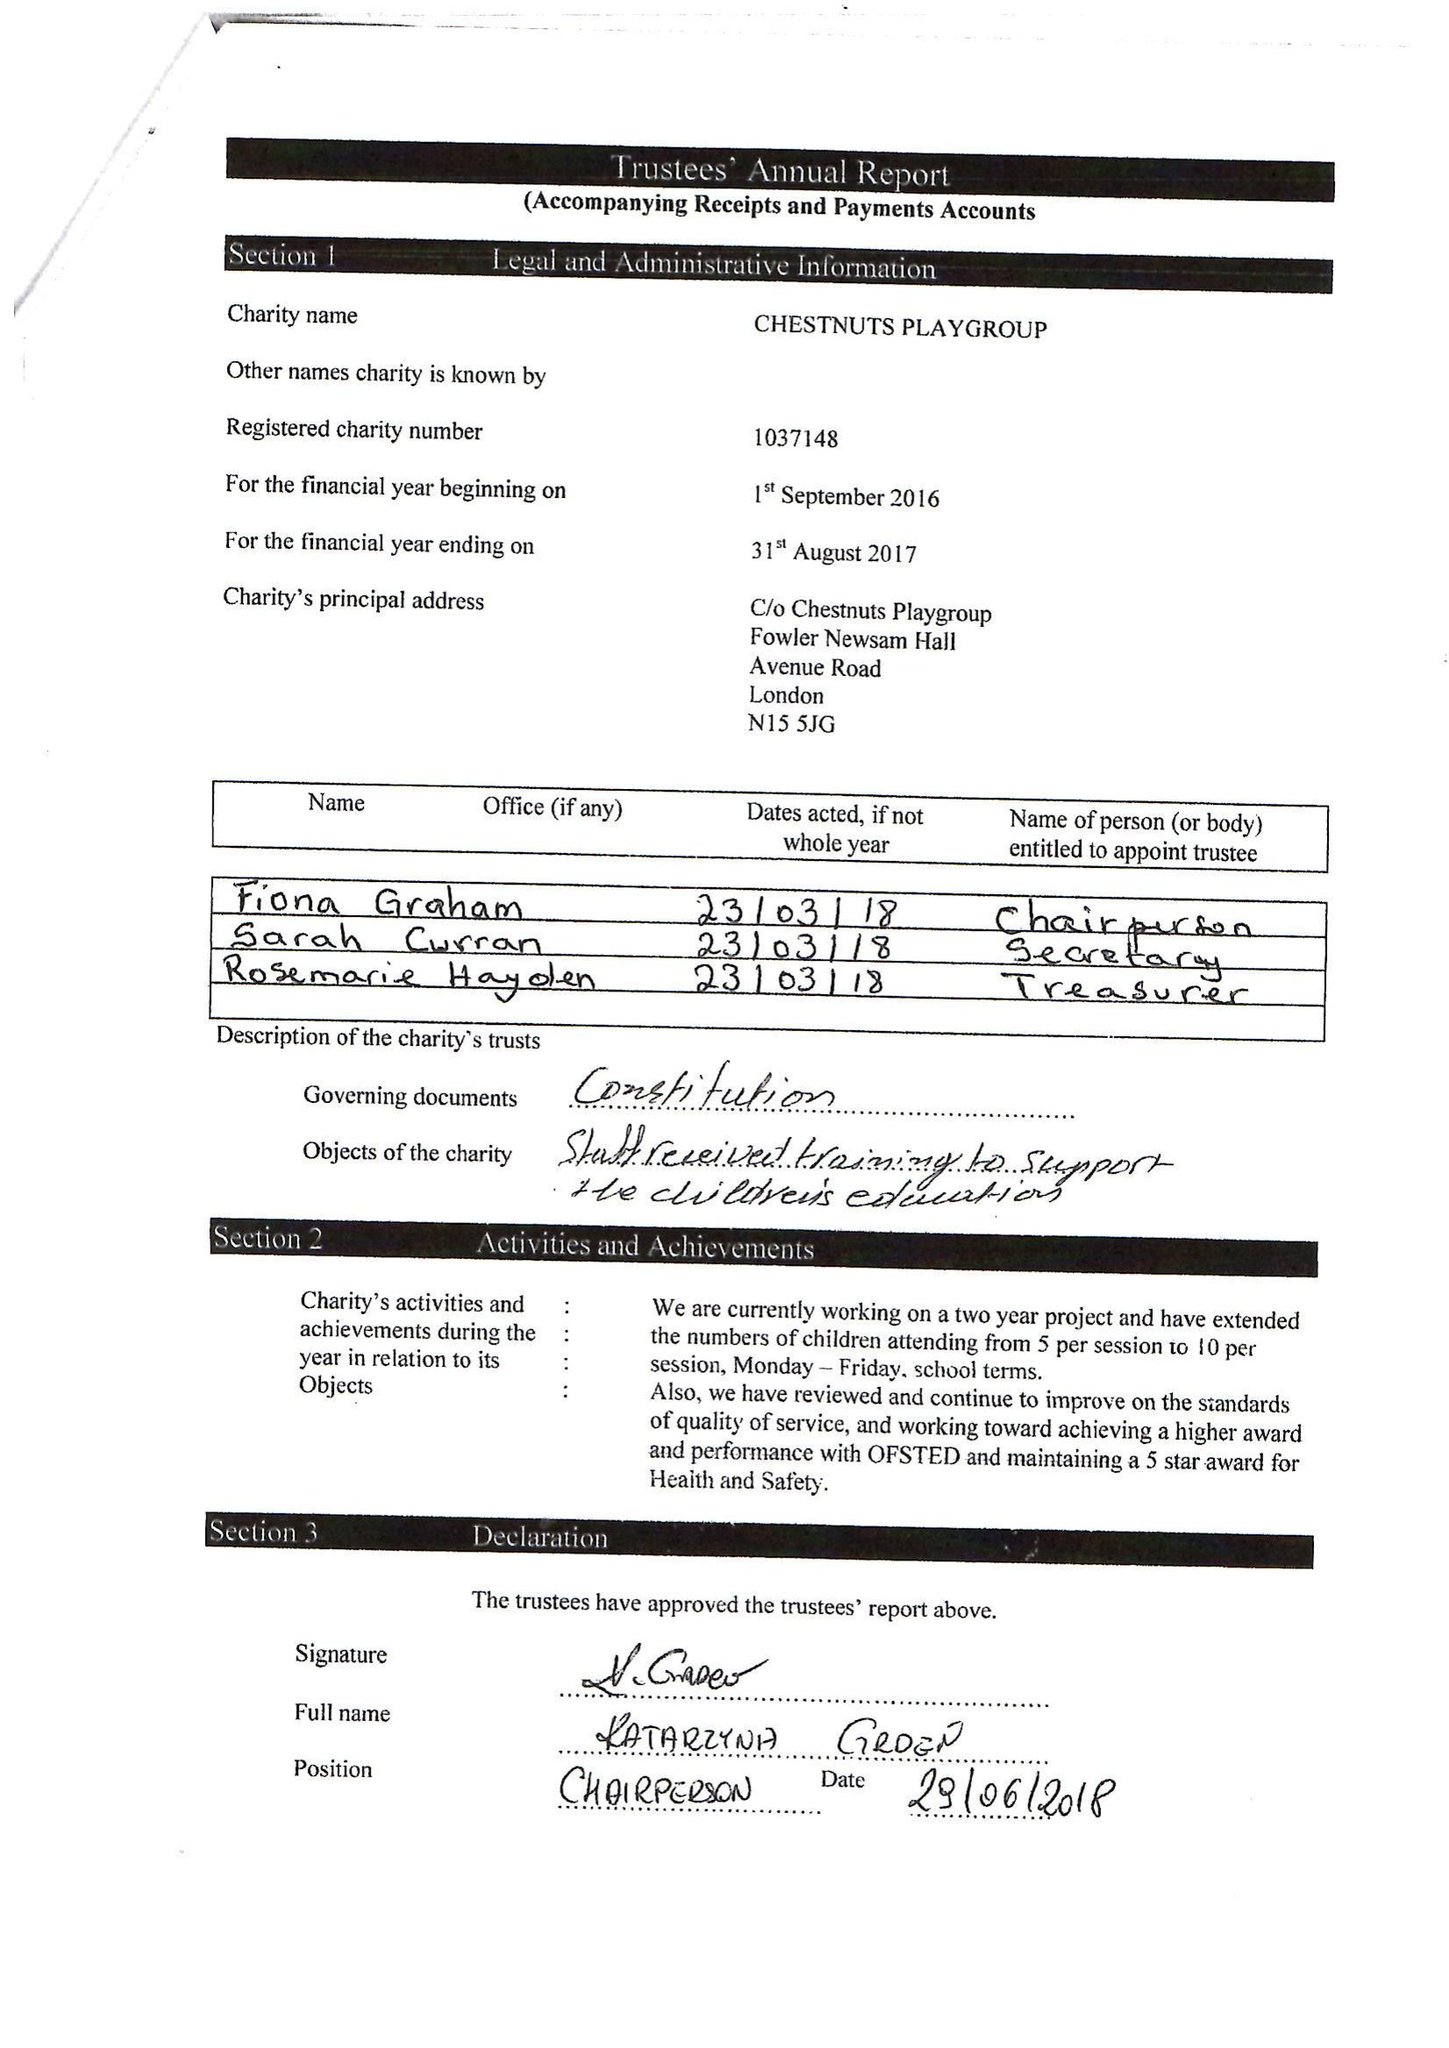What is the value for the income_annually_in_british_pounds?
Answer the question using a single word or phrase. 106447.00 